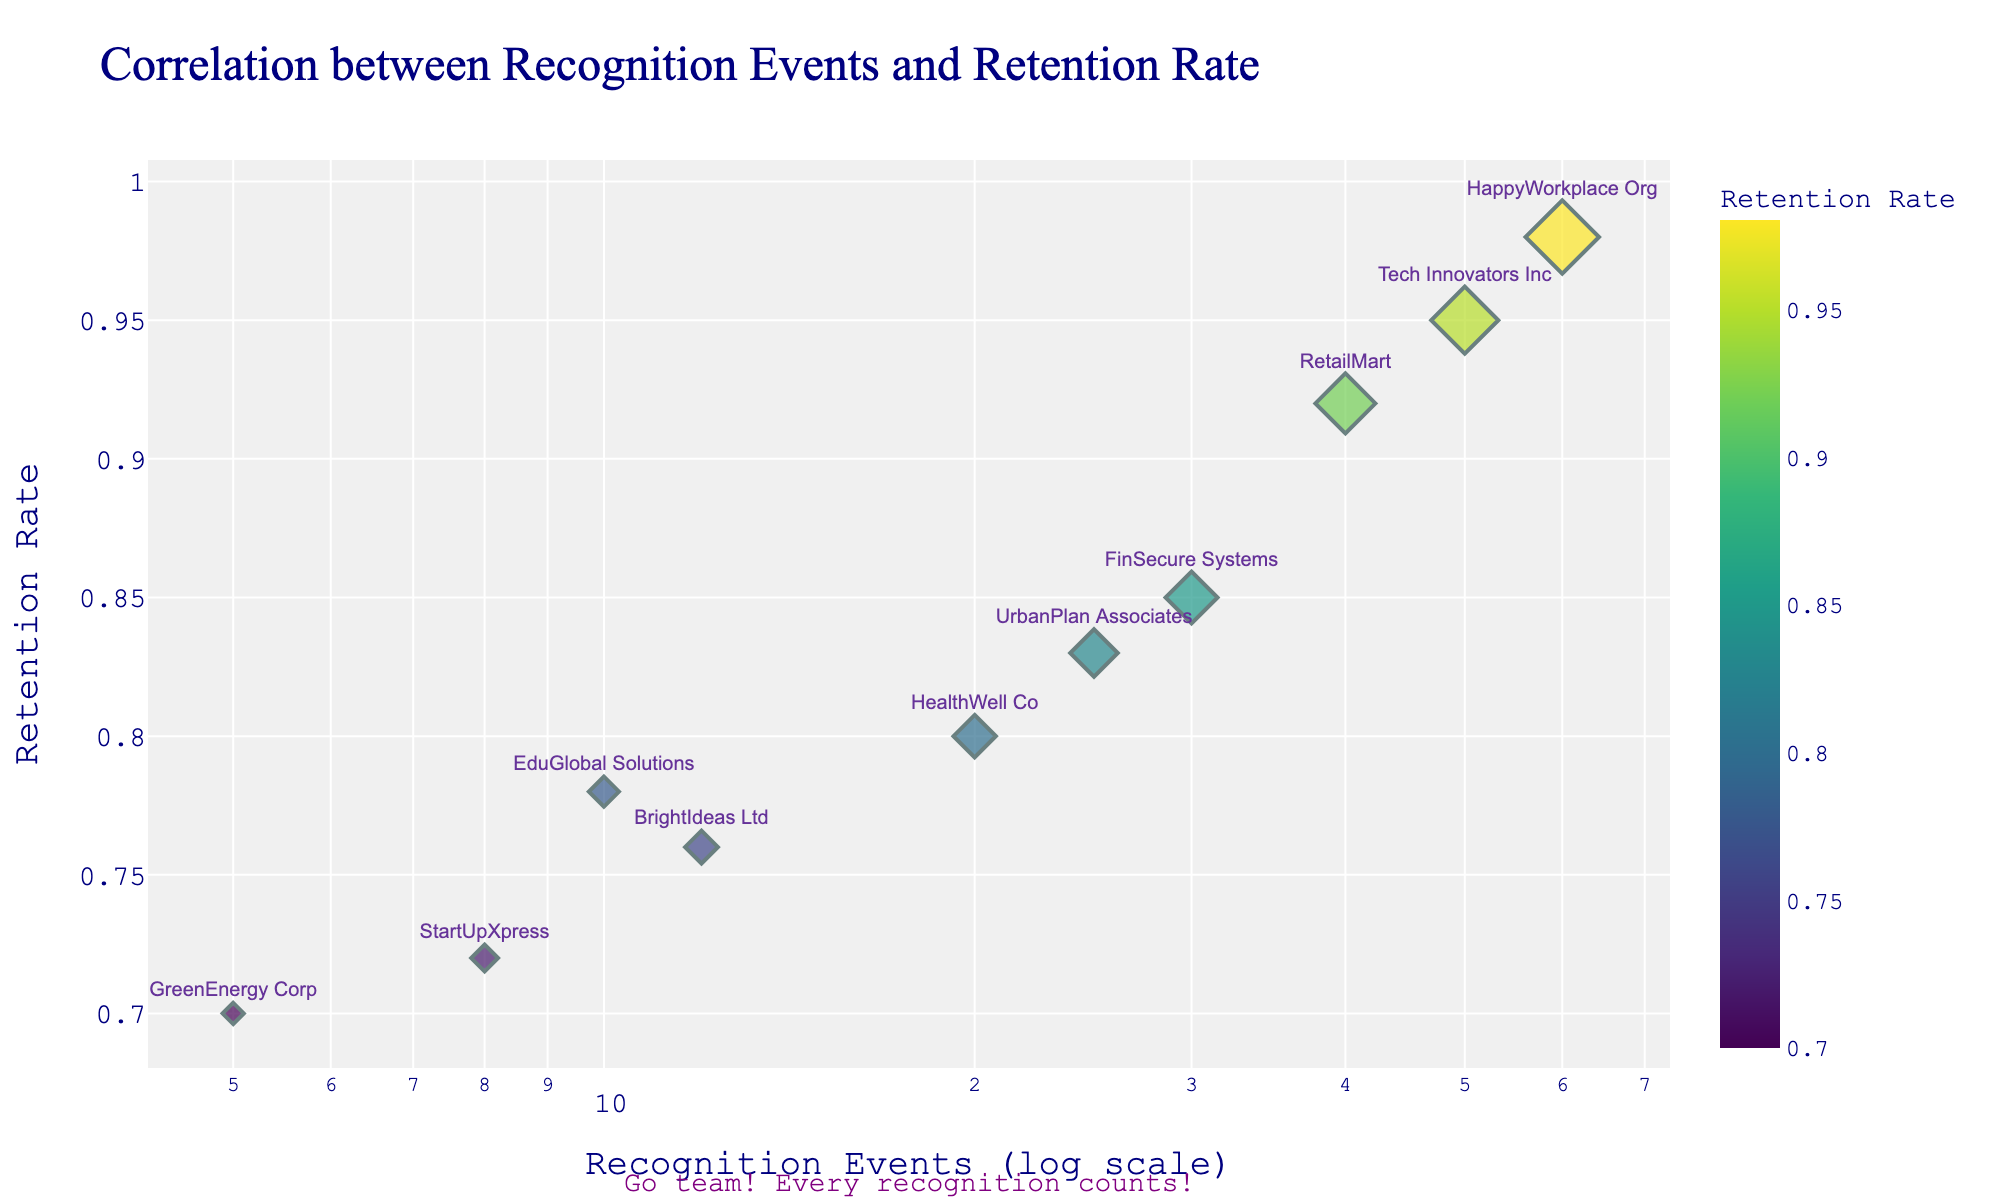What is the title of the scatter plot? The title is usually at the top center of the figure and provides a summary of what the plot represents. Referring to the title in the question will guide us to read the exact wording.
Answer: Correlation between Recognition Events and Retention Rate How many companies are represented in the scatter plot? To determine the number of companies, count the number of data points representing each company on the scatter plot.
Answer: 10 Which company has the highest retention rate and how many recognition events do they have? To answer this, find the data point with the highest y-value, then refer to its x-value to find the number of recognition events.
Answer: HappyWorkplace Org with 60 recognition events What is the overall trend between recognition events and retention rate in the plot? Observe the general direction of the points. If they tend to go upwards as they move to the right, the trend is positive.
Answer: Positive correlation Which company has the lowest number of recognition events, and what is their retention rate? Identify the data point with the smallest x-value and refer to its y-value for the retention rate.
Answer: GreenEnergy Corp with a retention rate of 0.70 Compare the retention rates of Tech Innovators Inc and GreenEnergy Corp. Which one is higher? By how much? Look at the y-values of both companies and find the difference.
Answer: Tech Innovators Inc's rate is 0.25 higher What's the average retention rate of companies with more than 10 recognition events? First, filter out the companies with more than 10 recognition events, then calculate their average retention rate.
Answer: (0.95 + 0.85 + 0.92 + 0.98 + 0.83) / 5 = 0.906 Do companies with fewer than 10 recognition events have retention rates above 0.75? Look at the y-values of the companies with x-values less than 10. Check if all values are above 0.75.
Answer: No, they do not; 0.70 and 0.72 are below 0.75 On a log scale, which company is halfway between the highest and lowest number of recognition events? Identify the companies with the highest and lowest x-values, find the midpoint logarithmically, and see which data point is closest.
Answer: UrbanPlan Associates How does the graphical representation of the recognition events change due to the log-x scale? Observe the spacing of the x-values; log scale makes smaller numbers appear more spaced out and larger numbers condensed.
Answer: The log scale compresses larger x-values and spreads out smaller x-values 